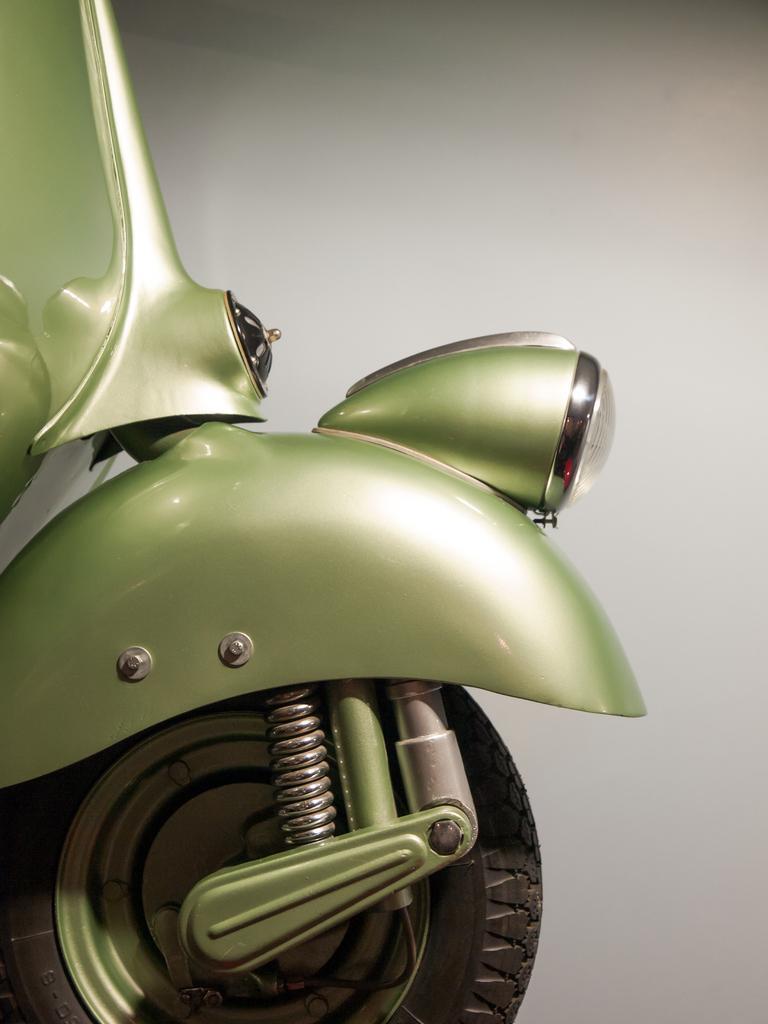How would you summarize this image in a sentence or two? In this picture we can see the front part of a vehicle along with a wheel. 